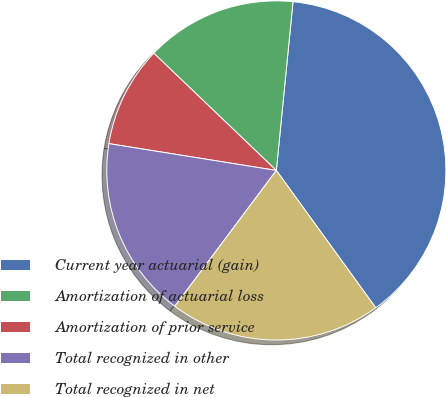<chart> <loc_0><loc_0><loc_500><loc_500><pie_chart><fcel>Current year actuarial (gain)<fcel>Amortization of actuarial loss<fcel>Amortization of prior service<fcel>Total recognized in other<fcel>Total recognized in net<nl><fcel>38.46%<fcel>14.42%<fcel>9.62%<fcel>17.31%<fcel>20.19%<nl></chart> 